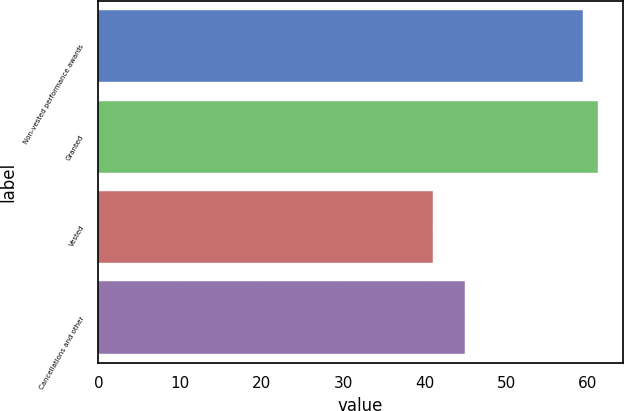Convert chart to OTSL. <chart><loc_0><loc_0><loc_500><loc_500><bar_chart><fcel>Non-vested performance awards<fcel>Granted<fcel>Vested<fcel>Cancellations and other<nl><fcel>59.36<fcel>61.26<fcel>41.01<fcel>44.93<nl></chart> 